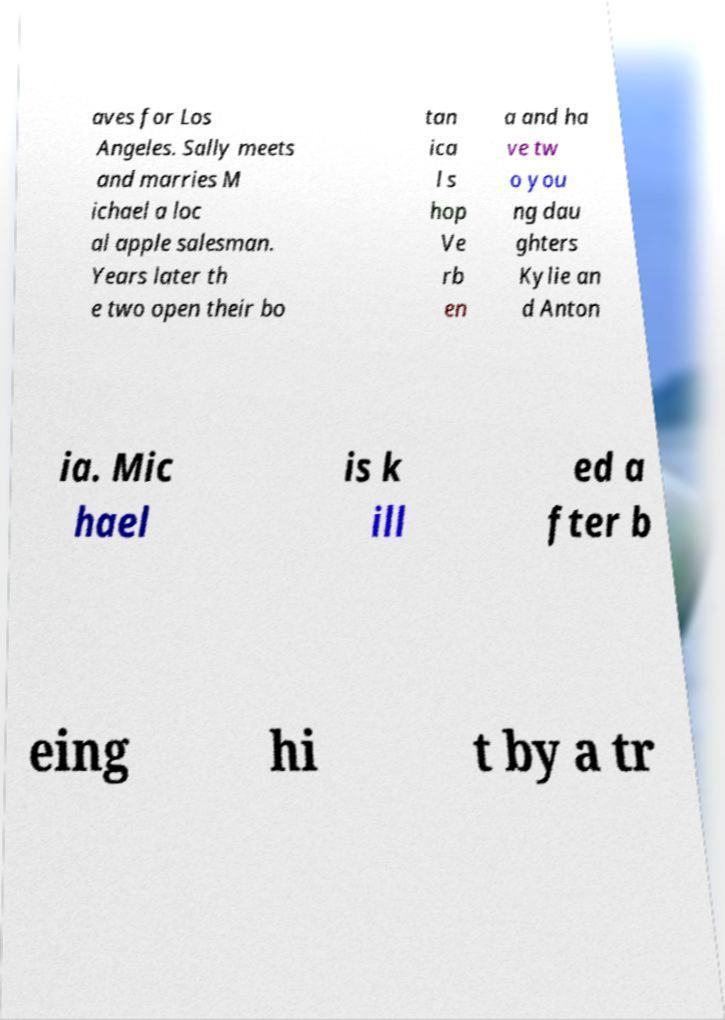Could you extract and type out the text from this image? aves for Los Angeles. Sally meets and marries M ichael a loc al apple salesman. Years later th e two open their bo tan ica l s hop Ve rb en a and ha ve tw o you ng dau ghters Kylie an d Anton ia. Mic hael is k ill ed a fter b eing hi t by a tr 